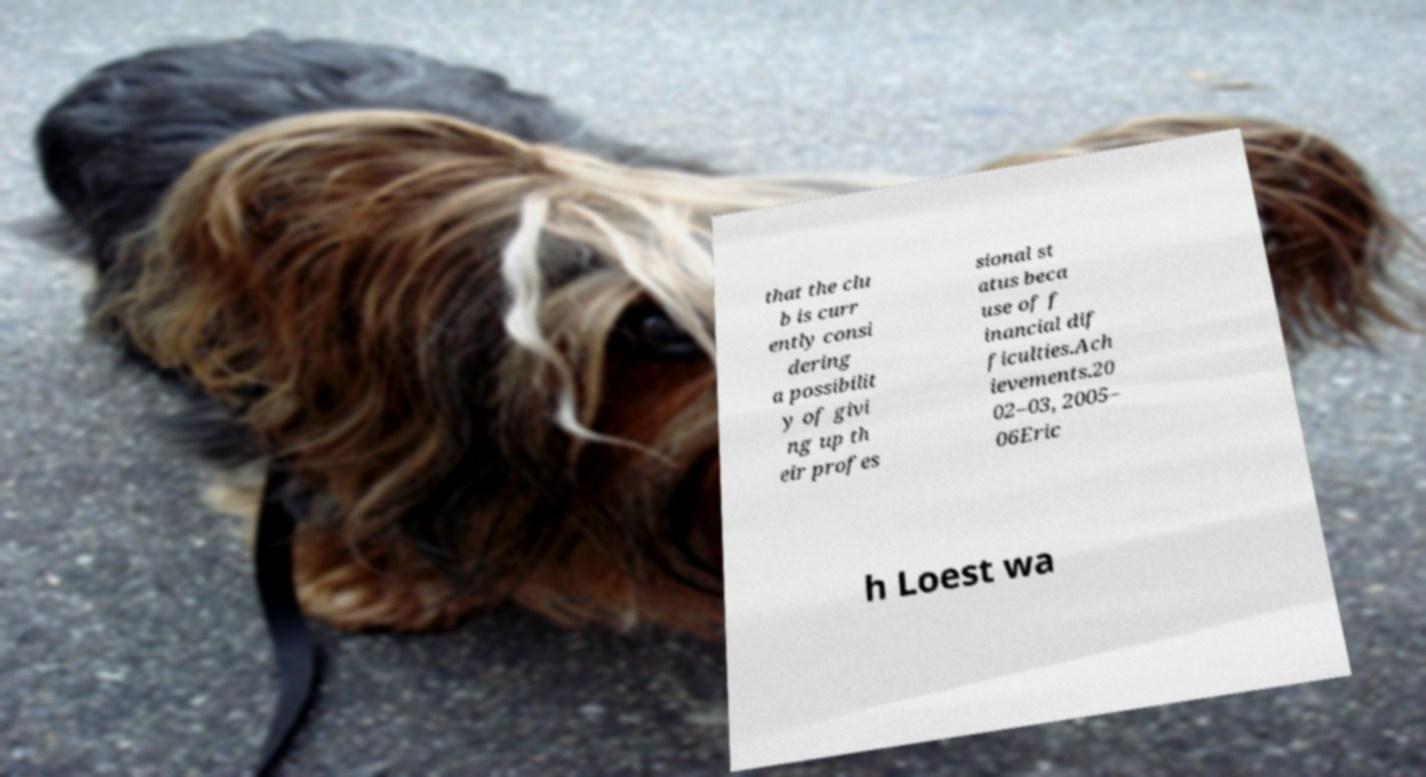I need the written content from this picture converted into text. Can you do that? that the clu b is curr ently consi dering a possibilit y of givi ng up th eir profes sional st atus beca use of f inancial dif ficulties.Ach ievements.20 02–03, 2005– 06Eric h Loest wa 